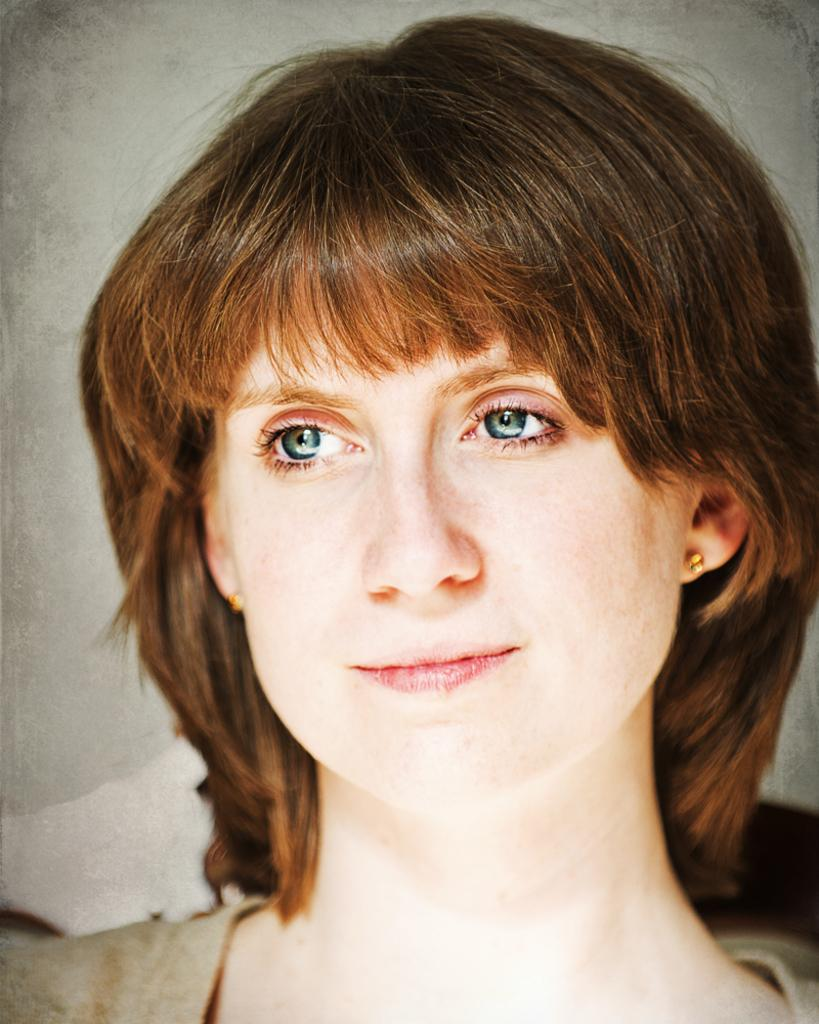What is the main subject of the image? There is a woman's face in the image. How many robins can be seen flying over the houses in the image? There are no robins or houses present in the image; it only features a woman's face. 